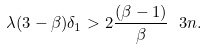<formula> <loc_0><loc_0><loc_500><loc_500>\lambda ( 3 - \beta ) \delta _ { 1 } > 2 \frac { ( \beta - 1 ) } { \beta } \ 3 n .</formula> 